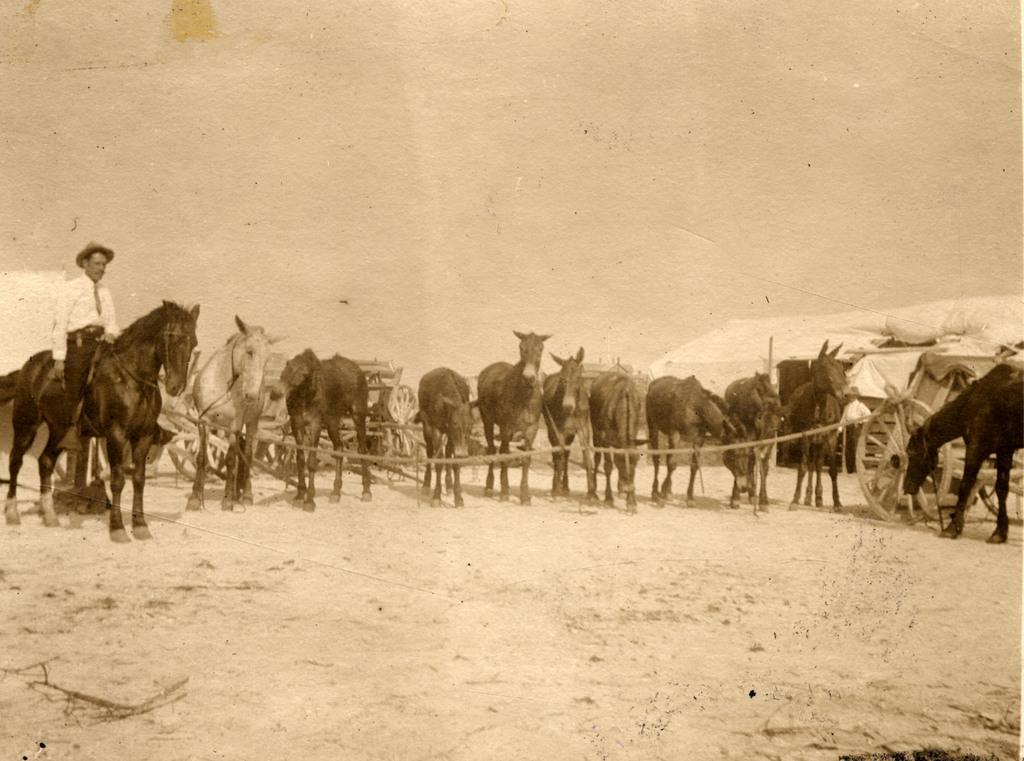Please provide a concise description of this image. In this picture we can see a group of horses standing, carts on the ground and a man sitting on a horse and this is a black and white picture. 